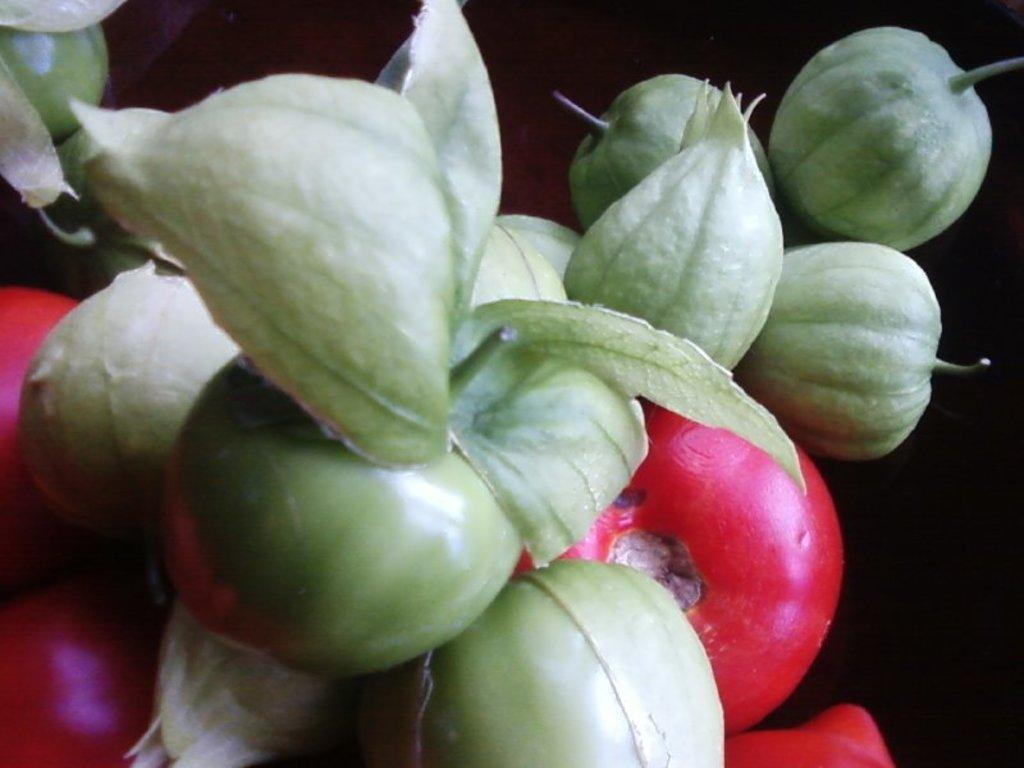What type of food items can be seen in the image? There are vegetables in the image. What type of ornament is hanging from the vegetables in the image? There is no ornament present in the image; it only features vegetables. 